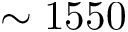Convert formula to latex. <formula><loc_0><loc_0><loc_500><loc_500>\sim 1 5 5 0</formula> 